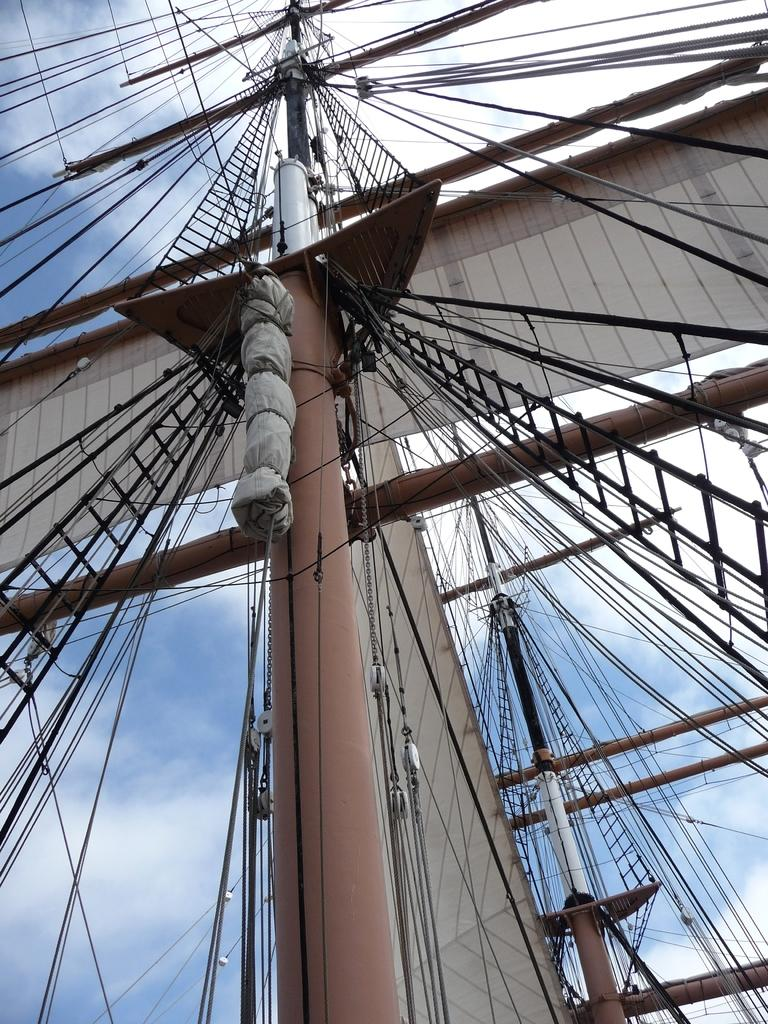What is the main subject of the image? The main subject of the image is a part of a ship. What other objects can be seen in the image? Poles, wires, ropes, and ladders are attached to the poles in the image. What can be seen in the background of the image? The sky and clouds are visible in the background of the image. What type of shirt is the belief wearing in the image? There is no person or belief present in the image, and therefore no shirt can be observed. 